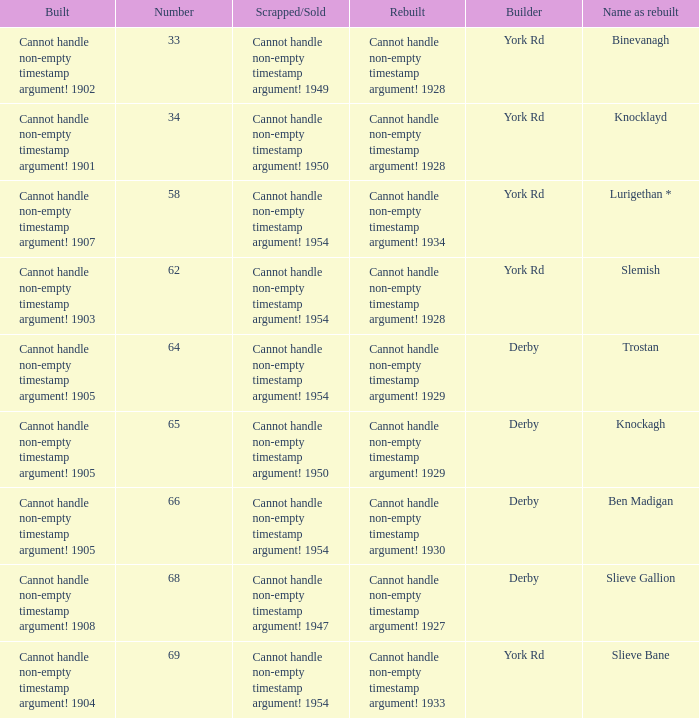Which Rebuilt has a Name as rebuilt of binevanagh? Cannot handle non-empty timestamp argument! 1928. Could you parse the entire table? {'header': ['Built', 'Number', 'Scrapped/Sold', 'Rebuilt', 'Builder', 'Name as rebuilt'], 'rows': [['Cannot handle non-empty timestamp argument! 1902', '33', 'Cannot handle non-empty timestamp argument! 1949', 'Cannot handle non-empty timestamp argument! 1928', 'York Rd', 'Binevanagh'], ['Cannot handle non-empty timestamp argument! 1901', '34', 'Cannot handle non-empty timestamp argument! 1950', 'Cannot handle non-empty timestamp argument! 1928', 'York Rd', 'Knocklayd'], ['Cannot handle non-empty timestamp argument! 1907', '58', 'Cannot handle non-empty timestamp argument! 1954', 'Cannot handle non-empty timestamp argument! 1934', 'York Rd', 'Lurigethan *'], ['Cannot handle non-empty timestamp argument! 1903', '62', 'Cannot handle non-empty timestamp argument! 1954', 'Cannot handle non-empty timestamp argument! 1928', 'York Rd', 'Slemish'], ['Cannot handle non-empty timestamp argument! 1905', '64', 'Cannot handle non-empty timestamp argument! 1954', 'Cannot handle non-empty timestamp argument! 1929', 'Derby', 'Trostan'], ['Cannot handle non-empty timestamp argument! 1905', '65', 'Cannot handle non-empty timestamp argument! 1950', 'Cannot handle non-empty timestamp argument! 1929', 'Derby', 'Knockagh'], ['Cannot handle non-empty timestamp argument! 1905', '66', 'Cannot handle non-empty timestamp argument! 1954', 'Cannot handle non-empty timestamp argument! 1930', 'Derby', 'Ben Madigan'], ['Cannot handle non-empty timestamp argument! 1908', '68', 'Cannot handle non-empty timestamp argument! 1947', 'Cannot handle non-empty timestamp argument! 1927', 'Derby', 'Slieve Gallion'], ['Cannot handle non-empty timestamp argument! 1904', '69', 'Cannot handle non-empty timestamp argument! 1954', 'Cannot handle non-empty timestamp argument! 1933', 'York Rd', 'Slieve Bane']]} 